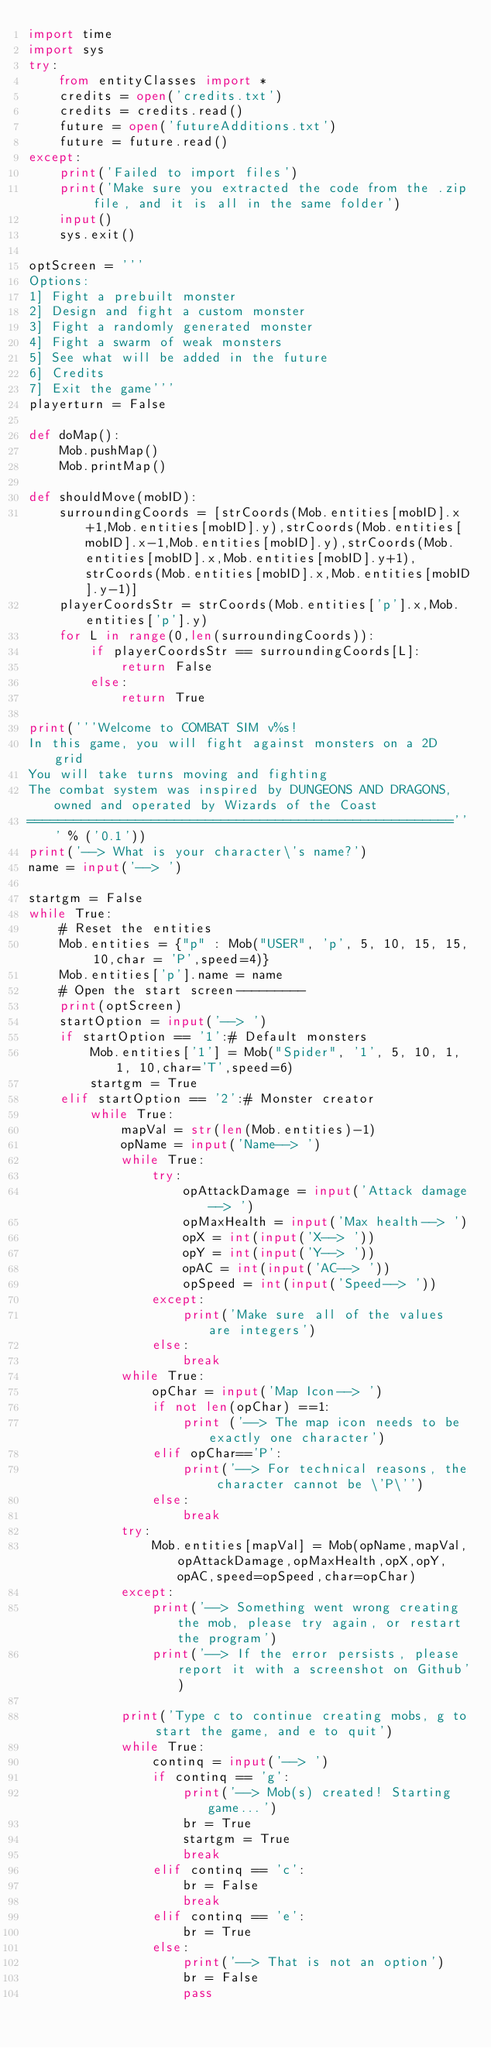<code> <loc_0><loc_0><loc_500><loc_500><_Python_>import time
import sys
try:
    from entityClasses import *
    credits = open('credits.txt')
    credits = credits.read()
    future = open('futureAdditions.txt')
    future = future.read()
except:
    print('Failed to import files')
    print('Make sure you extracted the code from the .zip file, and it is all in the same folder')
    input()
    sys.exit()

optScreen = '''
Options:
1] Fight a prebuilt monster
2] Design and fight a custom monster
3] Fight a randomly generated monster
4] Fight a swarm of weak monsters
5] See what will be added in the future
6] Credits
7] Exit the game'''
playerturn = False

def doMap():
    Mob.pushMap()
    Mob.printMap()

def shouldMove(mobID):
    surroundingCoords = [strCoords(Mob.entities[mobID].x+1,Mob.entities[mobID].y),strCoords(Mob.entities[mobID].x-1,Mob.entities[mobID].y),strCoords(Mob.entities[mobID].x,Mob.entities[mobID].y+1),strCoords(Mob.entities[mobID].x,Mob.entities[mobID].y-1)]
    playerCoordsStr = strCoords(Mob.entities['p'].x,Mob.entities['p'].y)
    for L in range(0,len(surroundingCoords)):
        if playerCoordsStr == surroundingCoords[L]:
            return False
        else:
            return True

print('''Welcome to COMBAT SIM v%s!
In this game, you will fight against monsters on a 2D grid
You will take turns moving and fighting
The combat system was inspired by DUNGEONS AND DRAGONS, owned and operated by Wizards of the Coast
=======================================================''' % ('0.1'))
print('--> What is your character\'s name?')
name = input('--> ')

startgm = False
while True:
    # Reset the entities
    Mob.entities = {"p" : Mob("USER", 'p', 5, 10, 15, 15, 10,char = 'P',speed=4)}
    Mob.entities['p'].name = name
    # Open the start screen---------
    print(optScreen)
    startOption = input('--> ')
    if startOption == '1':# Default monsters
        Mob.entities['1'] = Mob("Spider", '1', 5, 10, 1, 1, 10,char='T',speed=6)
        startgm = True
    elif startOption == '2':# Monster creator
        while True:
            mapVal = str(len(Mob.entities)-1)
            opName = input('Name--> ')
            while True:
                try:
                    opAttackDamage = input('Attack damage--> ')
                    opMaxHealth = input('Max health--> ')
                    opX = int(input('X--> '))
                    opY = int(input('Y--> '))
                    opAC = int(input('AC--> '))
                    opSpeed = int(input('Speed--> '))
                except:
                    print('Make sure all of the values are integers')
                else:
                    break
            while True:
                opChar = input('Map Icon--> ')
                if not len(opChar) ==1:
                    print ('--> The map icon needs to be exactly one character')
                elif opChar=='P':
                    print('--> For technical reasons, the character cannot be \'P\'')
                else:
                    break
            try:
                Mob.entities[mapVal] = Mob(opName,mapVal,opAttackDamage,opMaxHealth,opX,opY,opAC,speed=opSpeed,char=opChar)
            except:
                print('--> Something went wrong creating the mob, please try again, or restart the program')
                print('--> If the error persists, please report it with a screenshot on Github')
            
            print('Type c to continue creating mobs, g to start the game, and e to quit')
            while True:
                continq = input('--> ')
                if continq == 'g':
                    print('--> Mob(s) created! Starting game...')
                    br = True
                    startgm = True
                    break
                elif continq == 'c':
                    br = False
                    break
                elif continq == 'e':
                    br = True
                else:
                    print('--> That is not an option')
                    br = False
                    pass</code> 